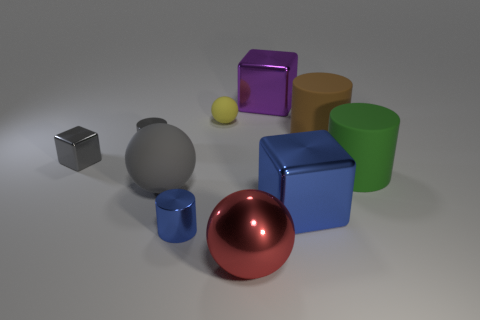Are there fewer big things that are on the right side of the large brown cylinder than large matte cylinders?
Keep it short and to the point. Yes. What is the color of the object that is behind the brown object and on the left side of the purple metal cube?
Provide a succinct answer. Yellow. How many other things are the same shape as the green object?
Provide a succinct answer. 3. Are there fewer purple shiny cubes that are on the right side of the green object than big brown rubber objects on the right side of the blue shiny block?
Offer a terse response. Yes. Do the blue cylinder and the blue object right of the tiny matte ball have the same material?
Provide a succinct answer. Yes. Is there anything else that is made of the same material as the yellow sphere?
Your answer should be very brief. Yes. Are there more big blue cubes than tiny green cylinders?
Your response must be concise. Yes. The small blue shiny object in front of the big green cylinder that is in front of the cube behind the tiny gray shiny cylinder is what shape?
Give a very brief answer. Cylinder. Does the large sphere to the right of the yellow rubber sphere have the same material as the large ball that is behind the big metallic ball?
Offer a very short reply. No. There is a green thing that is made of the same material as the gray ball; what shape is it?
Make the answer very short. Cylinder. 